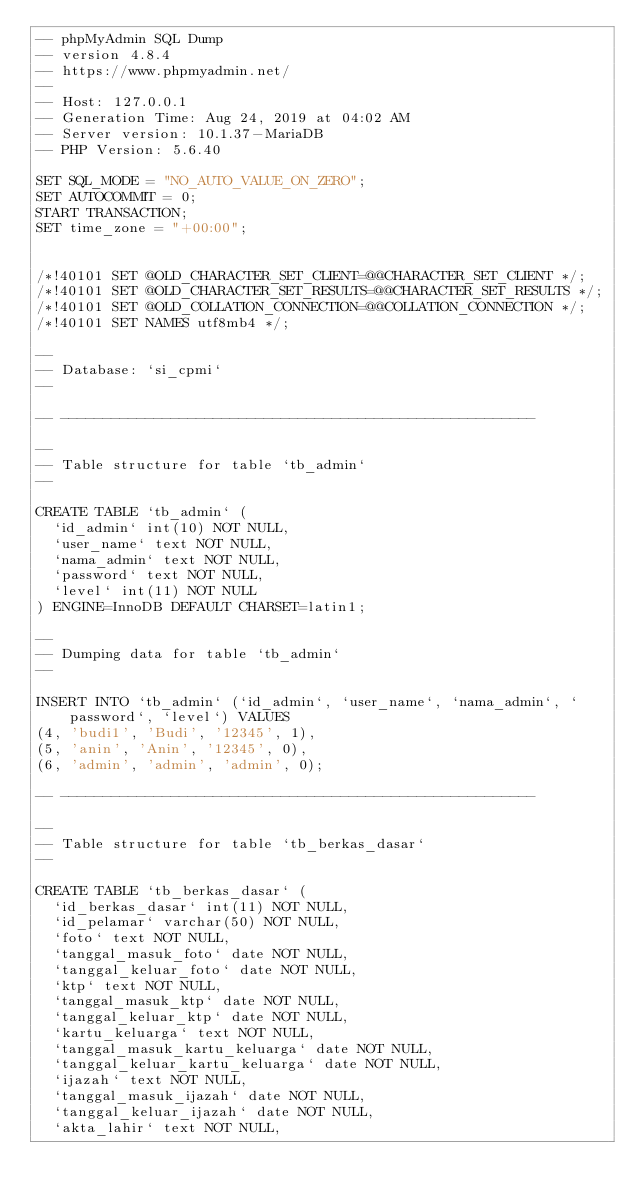<code> <loc_0><loc_0><loc_500><loc_500><_SQL_>-- phpMyAdmin SQL Dump
-- version 4.8.4
-- https://www.phpmyadmin.net/
--
-- Host: 127.0.0.1
-- Generation Time: Aug 24, 2019 at 04:02 AM
-- Server version: 10.1.37-MariaDB
-- PHP Version: 5.6.40

SET SQL_MODE = "NO_AUTO_VALUE_ON_ZERO";
SET AUTOCOMMIT = 0;
START TRANSACTION;
SET time_zone = "+00:00";


/*!40101 SET @OLD_CHARACTER_SET_CLIENT=@@CHARACTER_SET_CLIENT */;
/*!40101 SET @OLD_CHARACTER_SET_RESULTS=@@CHARACTER_SET_RESULTS */;
/*!40101 SET @OLD_COLLATION_CONNECTION=@@COLLATION_CONNECTION */;
/*!40101 SET NAMES utf8mb4 */;

--
-- Database: `si_cpmi`
--

-- --------------------------------------------------------

--
-- Table structure for table `tb_admin`
--

CREATE TABLE `tb_admin` (
  `id_admin` int(10) NOT NULL,
  `user_name` text NOT NULL,
  `nama_admin` text NOT NULL,
  `password` text NOT NULL,
  `level` int(11) NOT NULL
) ENGINE=InnoDB DEFAULT CHARSET=latin1;

--
-- Dumping data for table `tb_admin`
--

INSERT INTO `tb_admin` (`id_admin`, `user_name`, `nama_admin`, `password`, `level`) VALUES
(4, 'budi1', 'Budi', '12345', 1),
(5, 'anin', 'Anin', '12345', 0),
(6, 'admin', 'admin', 'admin', 0);

-- --------------------------------------------------------

--
-- Table structure for table `tb_berkas_dasar`
--

CREATE TABLE `tb_berkas_dasar` (
  `id_berkas_dasar` int(11) NOT NULL,
  `id_pelamar` varchar(50) NOT NULL,
  `foto` text NOT NULL,
  `tanggal_masuk_foto` date NOT NULL,
  `tanggal_keluar_foto` date NOT NULL,
  `ktp` text NOT NULL,
  `tanggal_masuk_ktp` date NOT NULL,
  `tanggal_keluar_ktp` date NOT NULL,
  `kartu_keluarga` text NOT NULL,
  `tanggal_masuk_kartu_keluarga` date NOT NULL,
  `tanggal_keluar_kartu_keluarga` date NOT NULL,
  `ijazah` text NOT NULL,
  `tanggal_masuk_ijazah` date NOT NULL,
  `tanggal_keluar_ijazah` date NOT NULL,
  `akta_lahir` text NOT NULL,</code> 